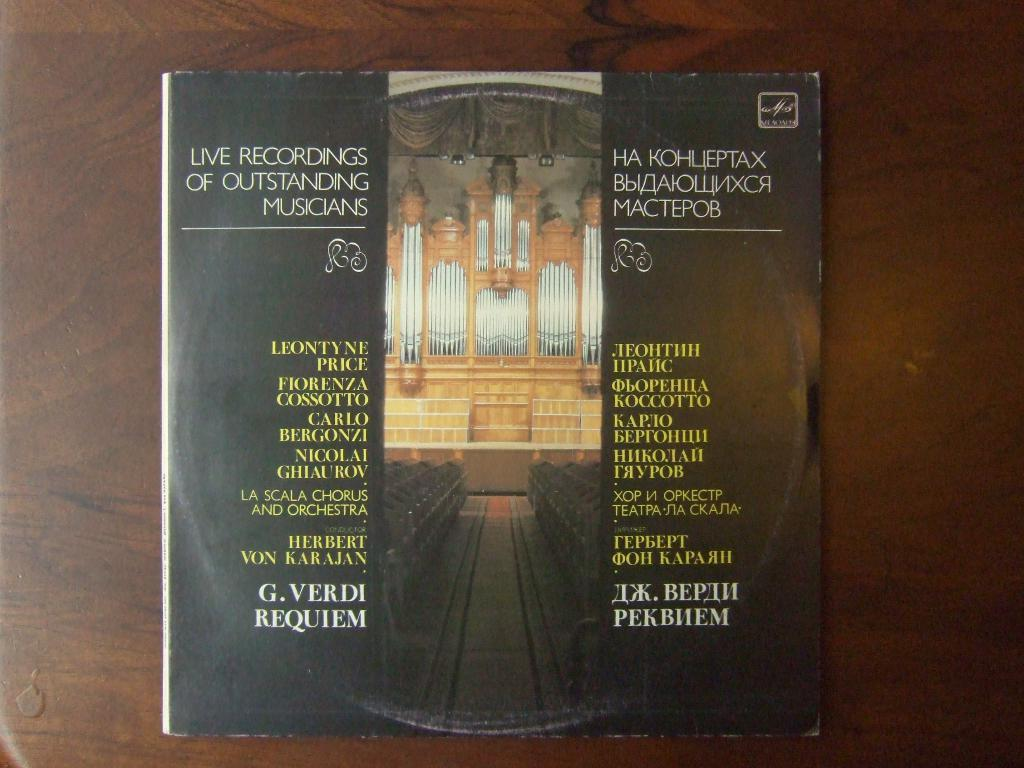<image>
Relay a brief, clear account of the picture shown. A record has live recordings of several musicians. 